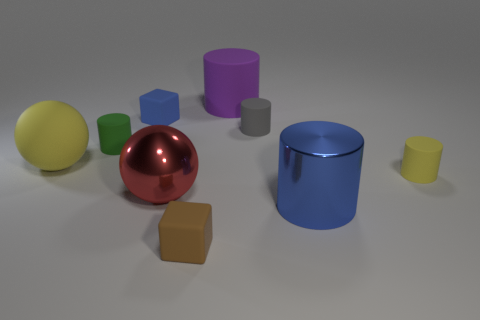Are there more big spheres that are in front of the big matte ball than small green objects right of the tiny blue thing? After carefully analysing the image, it's observed that there are a couple of big spheres in front of the big matte ball. However, the specifics regarding the small green objects located to the right of the tiny blue item are not explicitly clear without more context. An accurate count cannot be provided without additional details about the objects in question. 